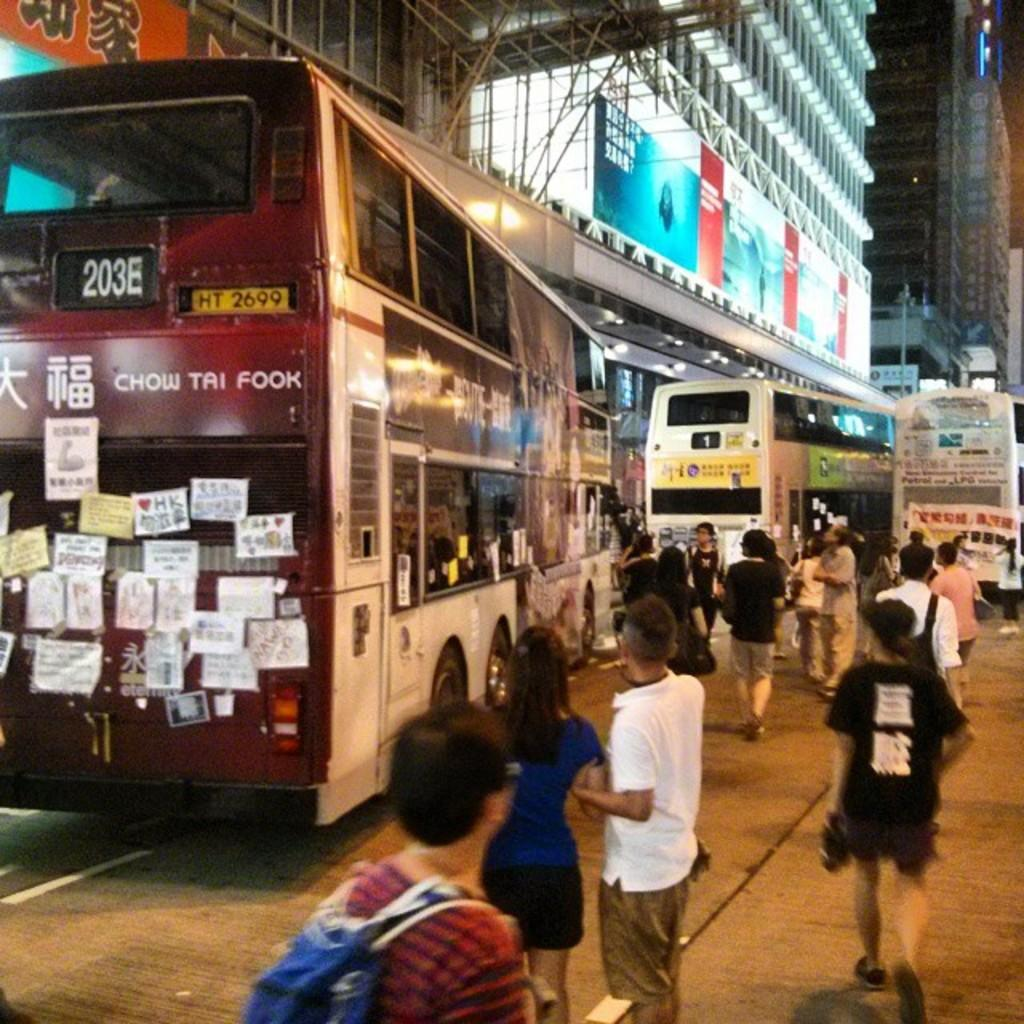<image>
Relay a brief, clear account of the picture shown. 203E is the designation of this public, double deck bus. 